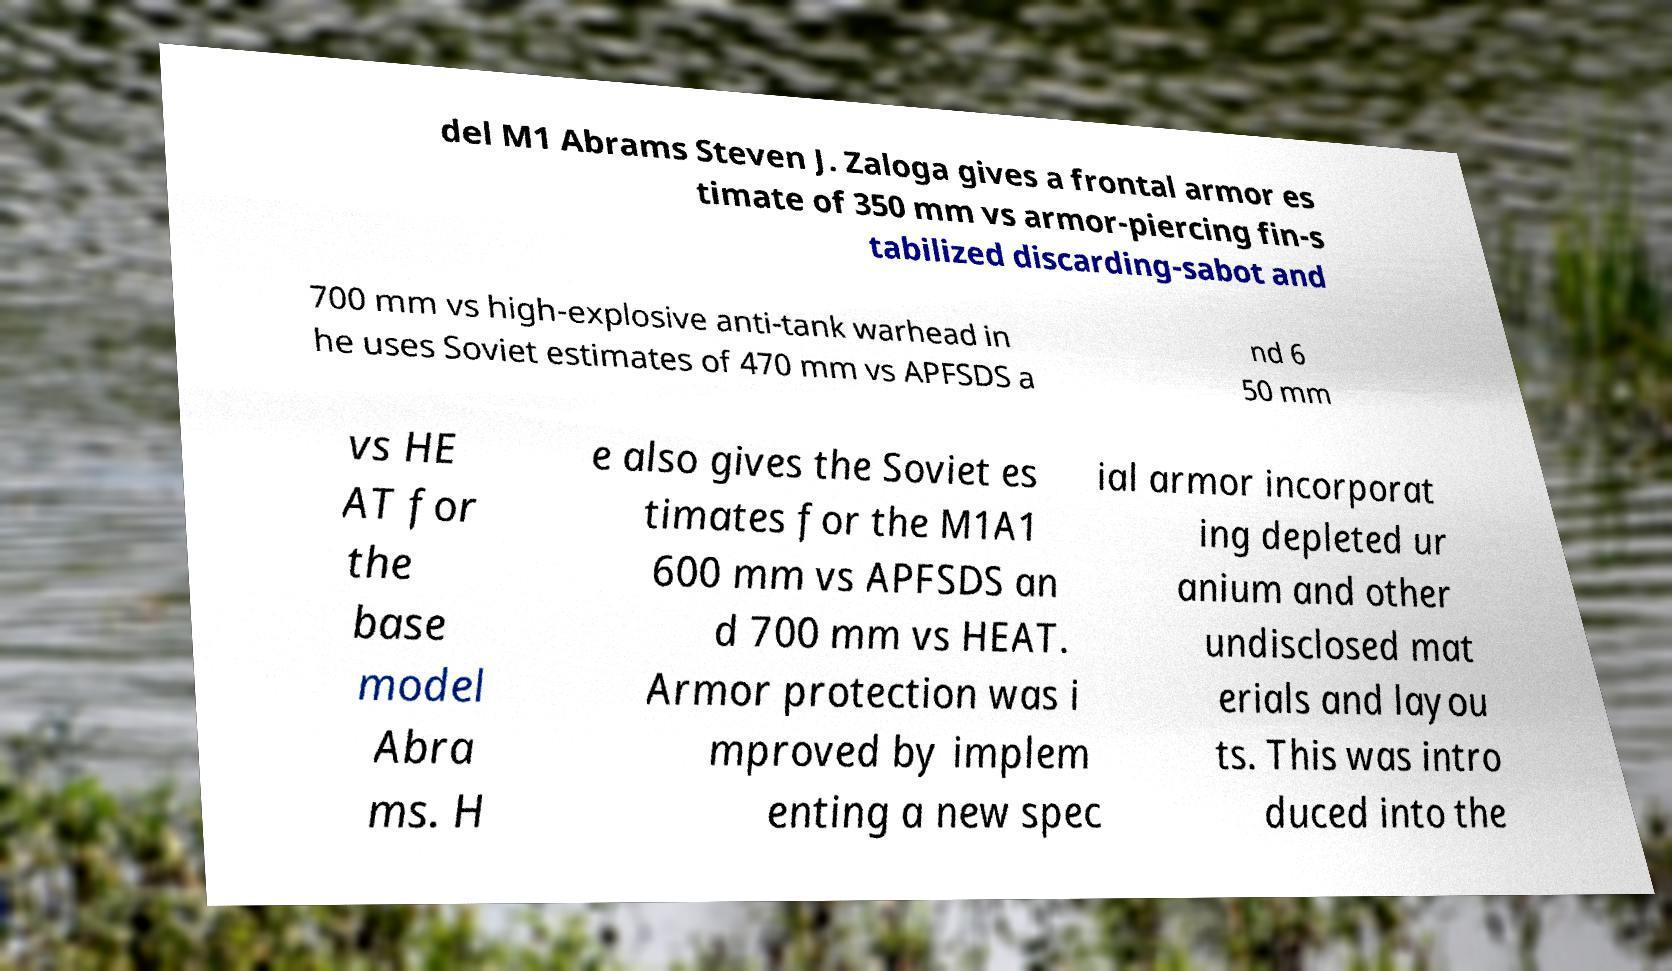I need the written content from this picture converted into text. Can you do that? del M1 Abrams Steven J. Zaloga gives a frontal armor es timate of 350 mm vs armor-piercing fin-s tabilized discarding-sabot and 700 mm vs high-explosive anti-tank warhead in he uses Soviet estimates of 470 mm vs APFSDS a nd 6 50 mm vs HE AT for the base model Abra ms. H e also gives the Soviet es timates for the M1A1 600 mm vs APFSDS an d 700 mm vs HEAT. Armor protection was i mproved by implem enting a new spec ial armor incorporat ing depleted ur anium and other undisclosed mat erials and layou ts. This was intro duced into the 